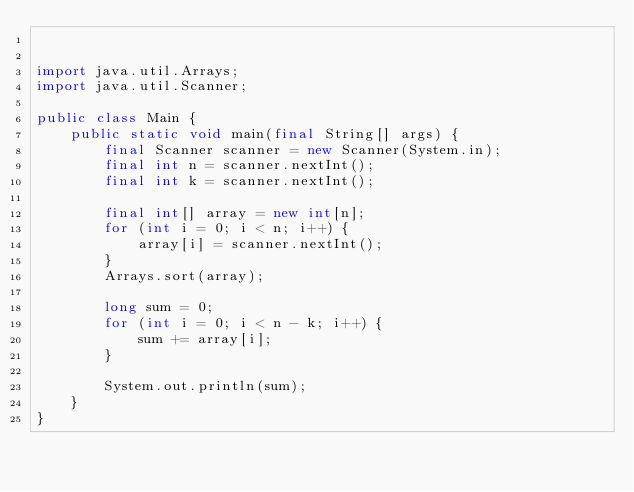<code> <loc_0><loc_0><loc_500><loc_500><_Java_>

import java.util.Arrays;
import java.util.Scanner;

public class Main {
    public static void main(final String[] args) {
        final Scanner scanner = new Scanner(System.in);
        final int n = scanner.nextInt();
        final int k = scanner.nextInt();

        final int[] array = new int[n];
        for (int i = 0; i < n; i++) {
            array[i] = scanner.nextInt();
        }
        Arrays.sort(array);

        long sum = 0;
        for (int i = 0; i < n - k; i++) {
            sum += array[i];
        }

        System.out.println(sum);
    }
}
</code> 